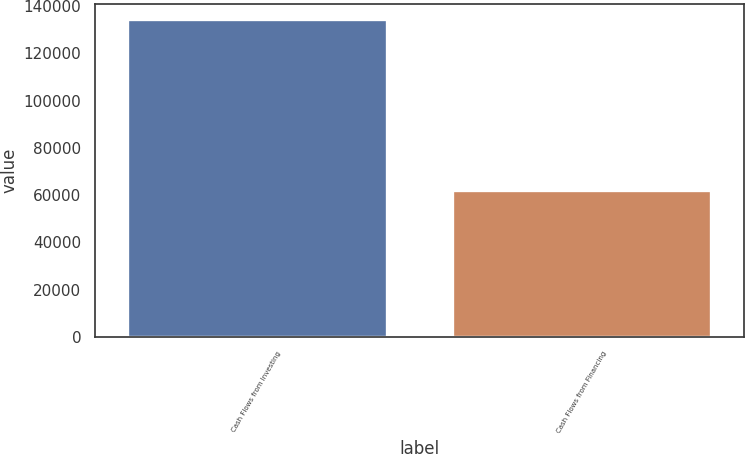Convert chart. <chart><loc_0><loc_0><loc_500><loc_500><bar_chart><fcel>Cash Flows from Investing<fcel>Cash Flows from Financing<nl><fcel>134272<fcel>62126<nl></chart> 